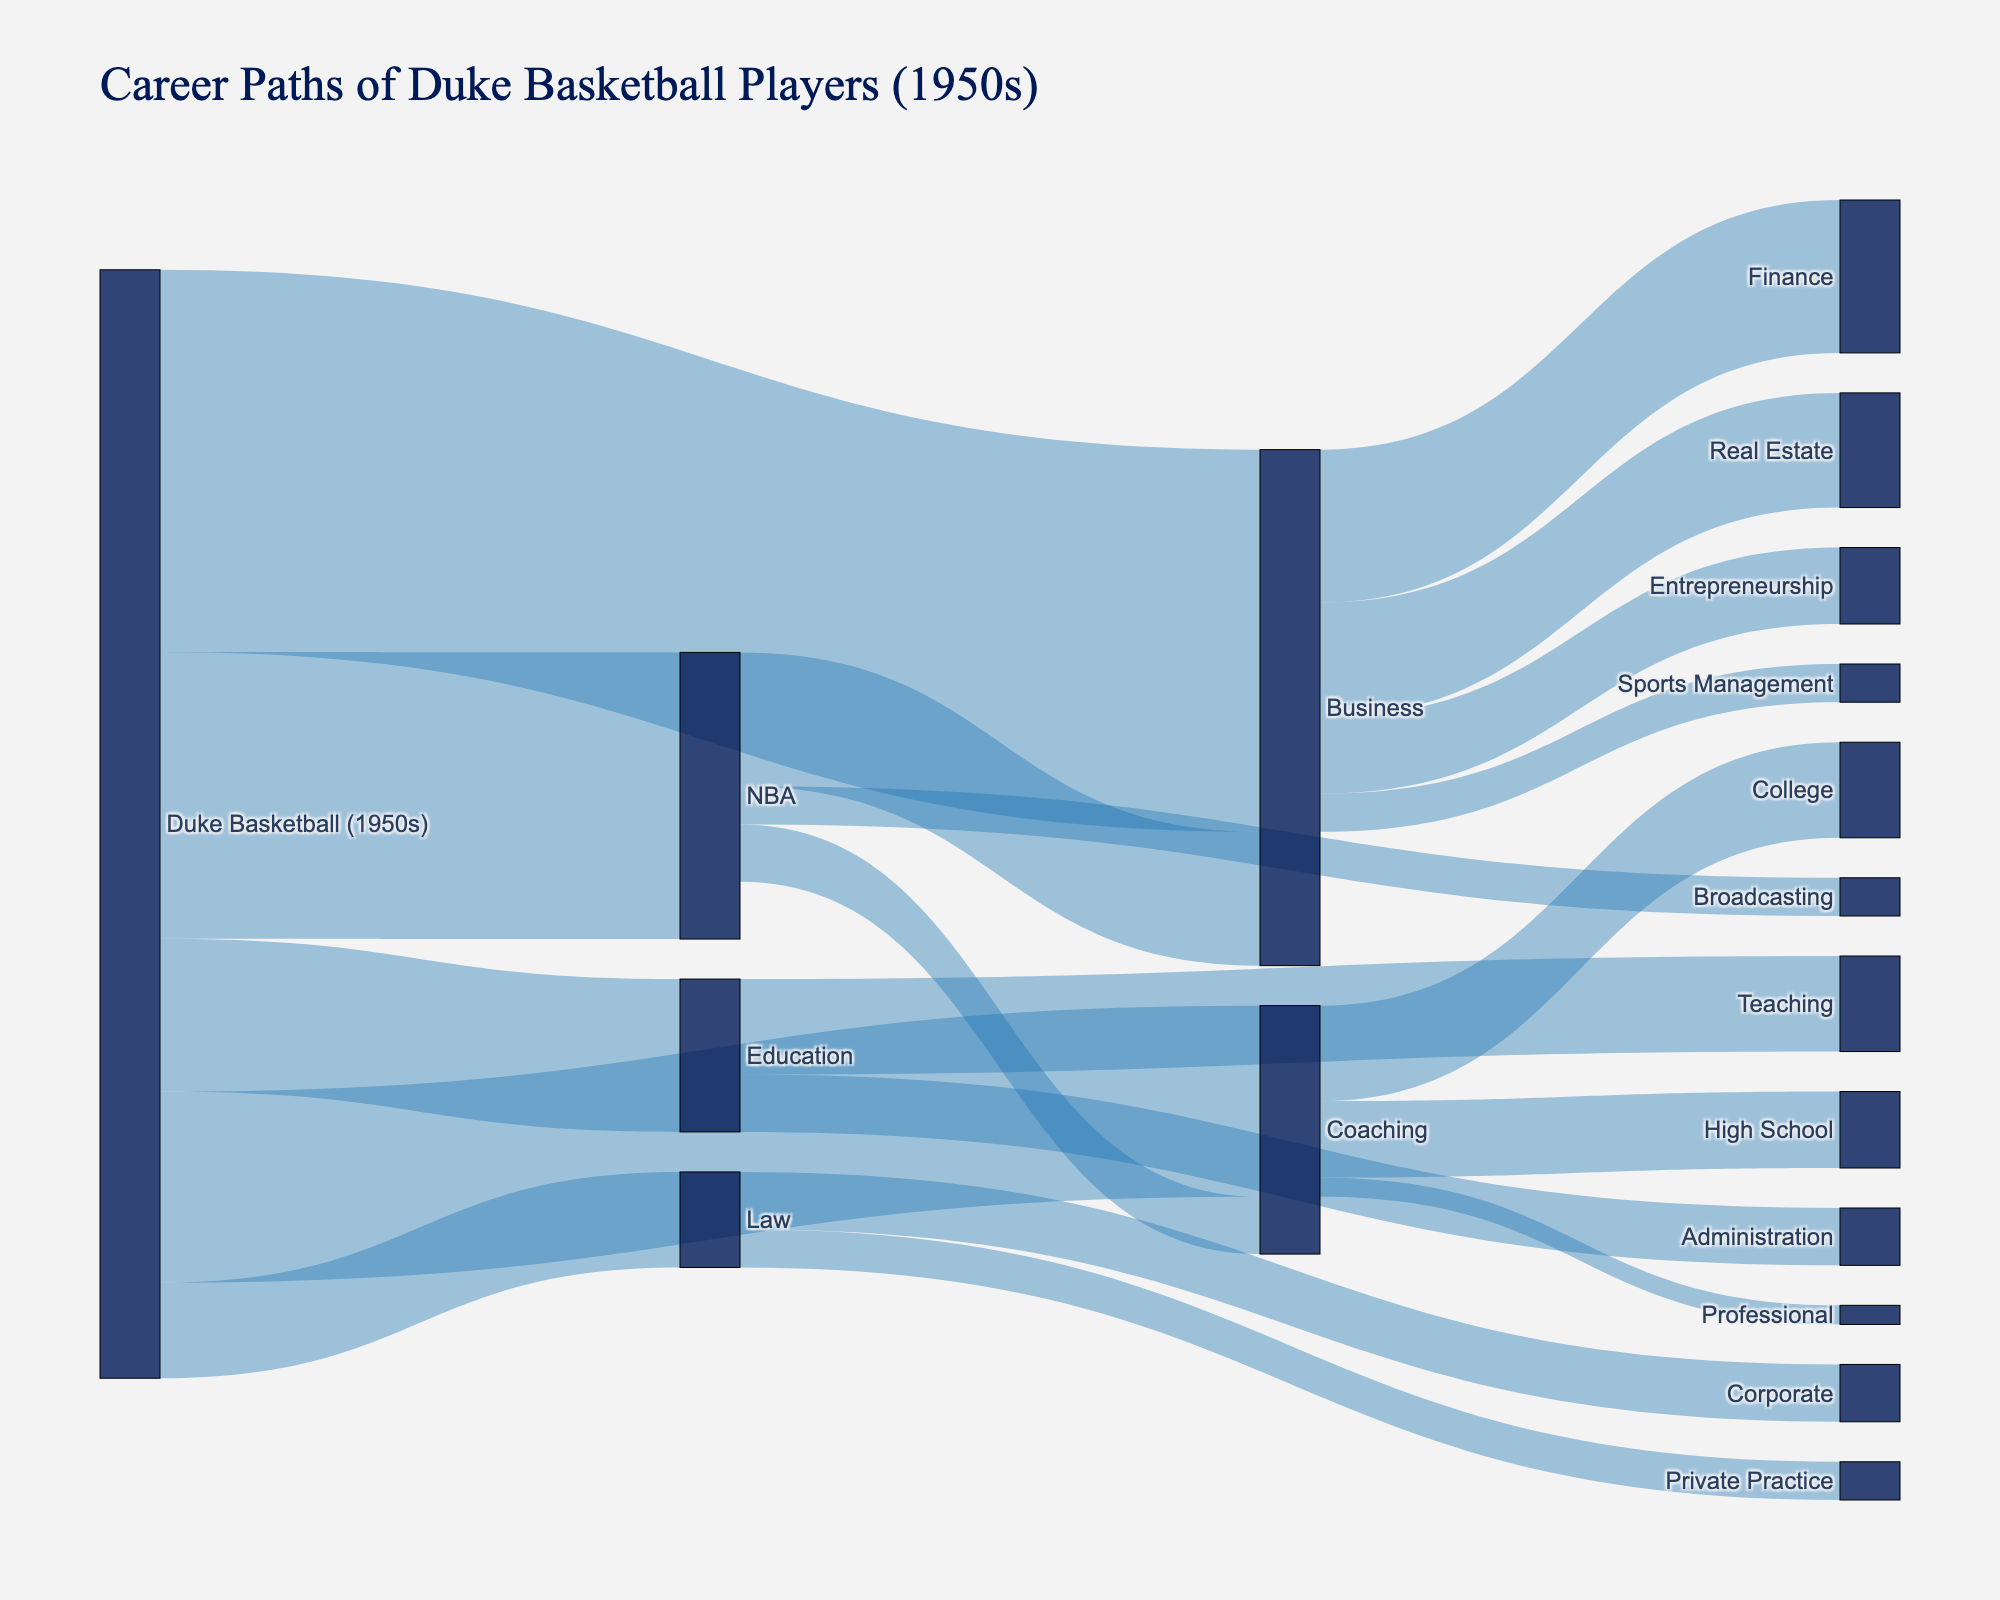What's the title of the diagram? The title of the diagram is located at the top and reads "Career Paths of Duke Basketball Players (1950s)".
Answer: Career Paths of Duke Basketball Players (1950s) How many players went from Duke Basketball to Business? From the diagram, the width of the flow from "Duke Basketball (1950s)" to "Business" represents 20 players.
Answer: 20 Which career path has the least number of players from Duke Basketball? The smallest flow from "Duke Basketball (1950s)" is to "Law", which represents 5 players.
Answer: Law How many players transitioned from the NBA to Broadcasting? The flow from "NBA" to "Broadcasting" shows 2 players.
Answer: 2 Which post-basketball profession did the most Duke basketball players from the 1950s pursue? The widest flow from "Duke Basketball (1950s)" leads to "Business", indicating it had the most players, with 20.
Answer: Business Compare the number of players who transitioned to Coaching from Duke Basketball and those who transitioned from the NBA to Business. To Coaching from Duke Basketball is 10, while from NBA to Business is 7. Coaching has more players by 3.
Answer: Coaching How many players transitioned from Coaching to College level coaching? The flow from "Coaching" to "College" represents 5 players.
Answer: 5 What is the total number of Duke basketball players who pursued a legal profession? The two segments from "Law" show 3 players in Corporate Law and 2 in Private Practice Law, totaling 5 players.
Answer: 5 What's the ratio of players who transitioned from NBA to Business compared to those who stayed in basketball-related careers after the NBA? From NBA to Business is 7, and from NBA to Coaching and Broadcasting together is 3+2 = 5. The ratio is 7:5.
Answer: 7:5 